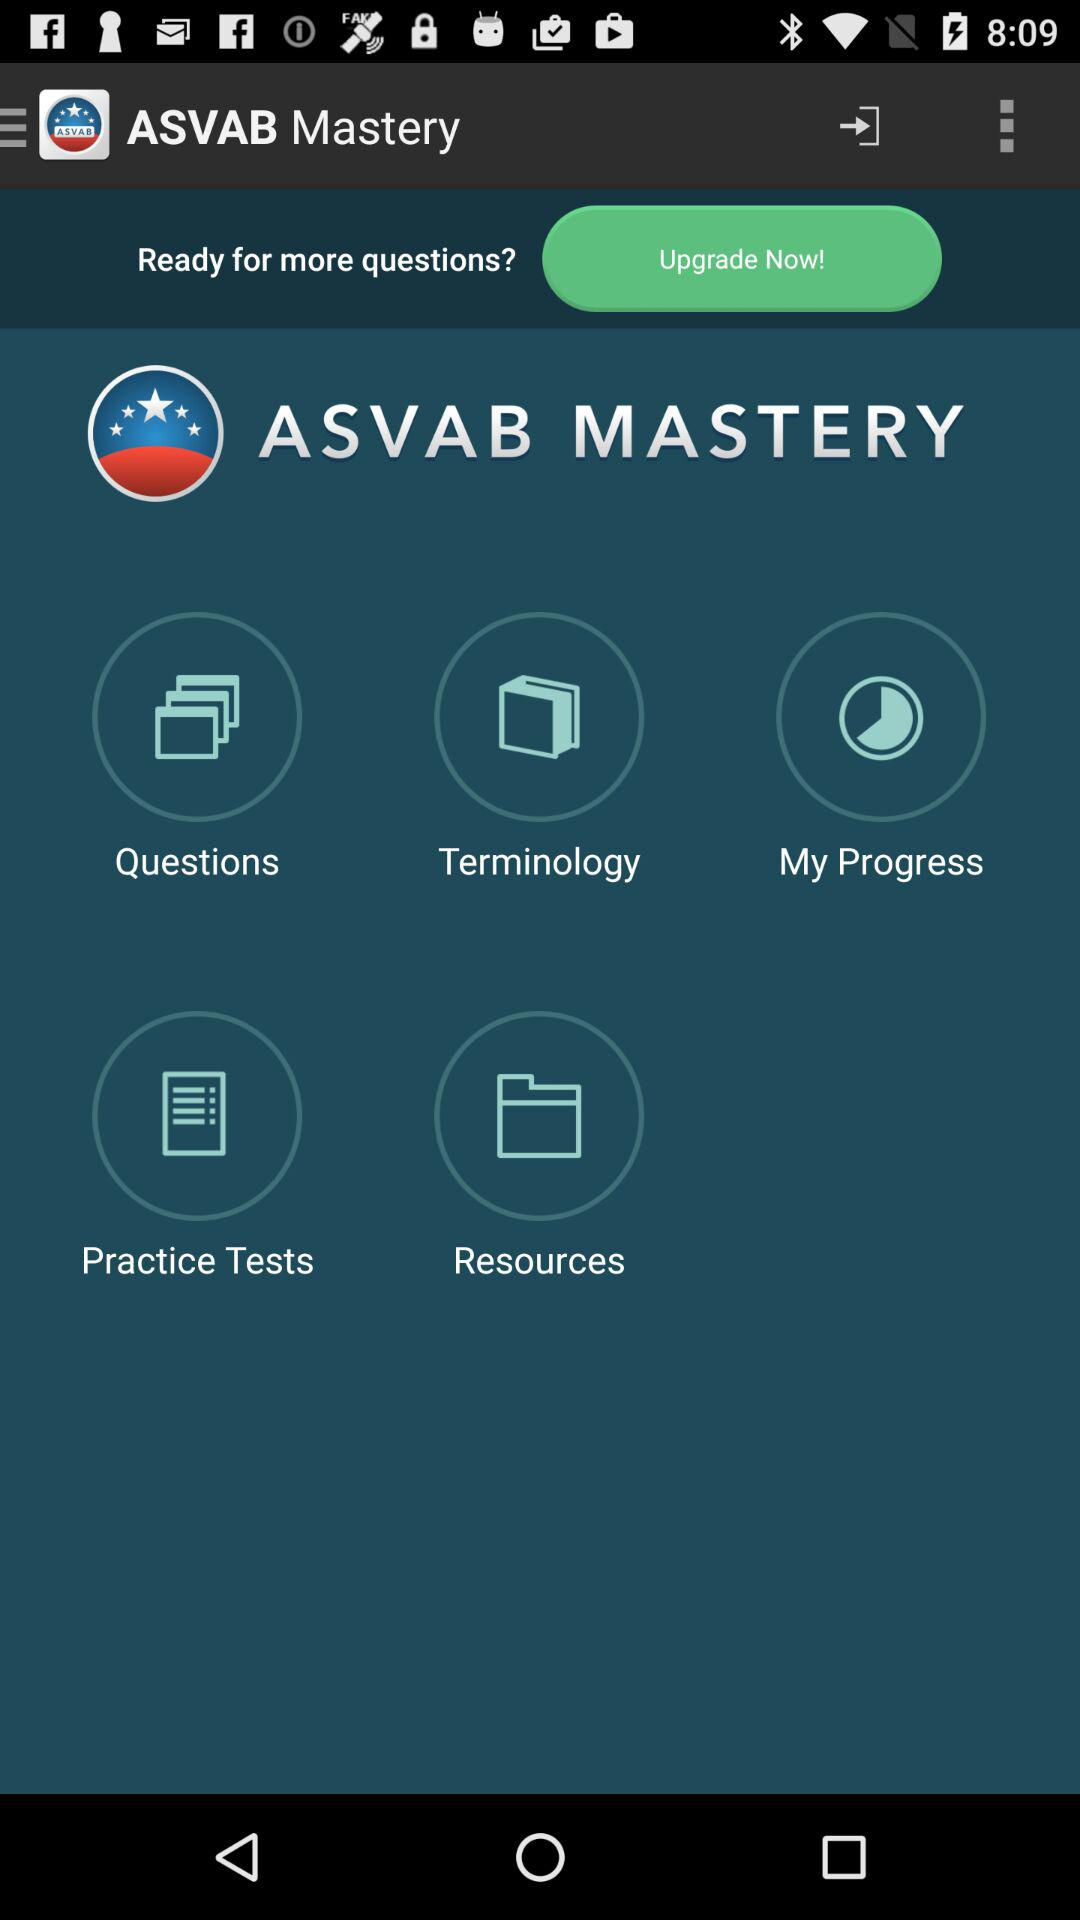How much does the upgrade cost?
When the provided information is insufficient, respond with <no answer>. <no answer> 